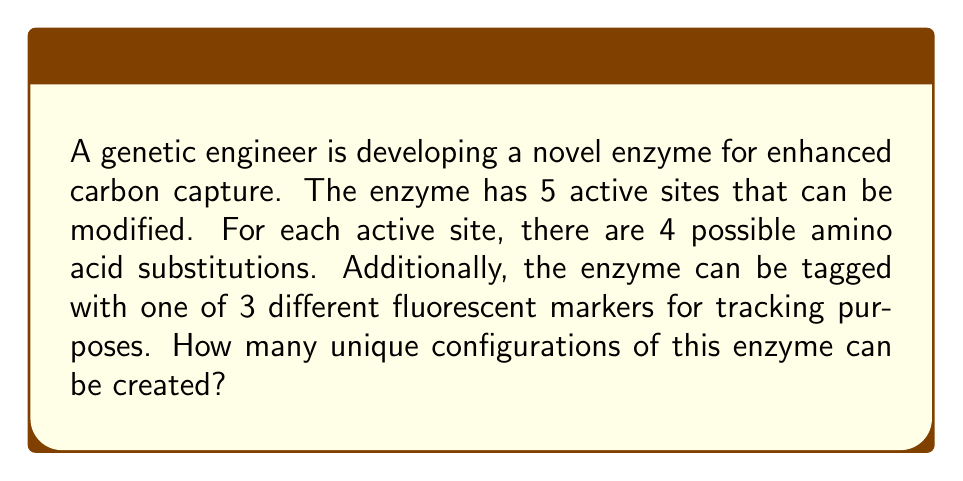Provide a solution to this math problem. Let's break this problem down step by step:

1. First, let's consider the active sites:
   - There are 5 active sites
   - Each site has 4 possible amino acid substitutions
   - This is a case of independent choices for each site

   The number of possible combinations for the active sites alone is:
   $$ 4^5 = 1024 $$

2. Now, let's consider the fluorescent markers:
   - There are 3 possible fluorescent markers
   - Only one marker can be used per enzyme

3. To find the total number of unique configurations, we multiply the number of active site combinations by the number of marker options:

   $$ \text{Total configurations} = 4^5 \times 3 $$

4. Calculate the final result:
   $$ 4^5 \times 3 = 1024 \times 3 = 3072 $$

This problem is an application of the multiplication principle in combinatorics. We multiply the number of choices for each independent decision to get the total number of possible outcomes.
Answer: $$ 3072 \text{ unique enzyme configurations} $$ 